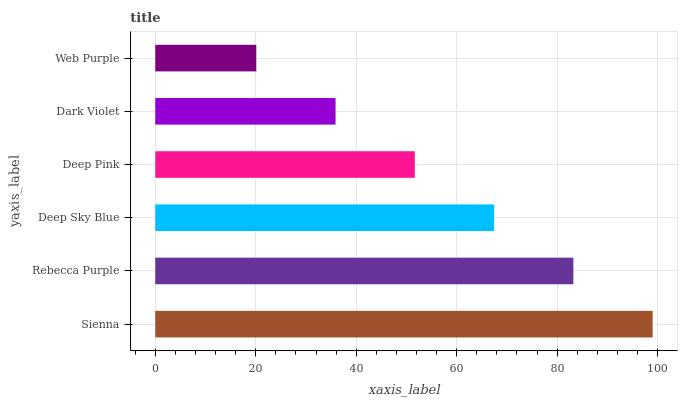Is Web Purple the minimum?
Answer yes or no. Yes. Is Sienna the maximum?
Answer yes or no. Yes. Is Rebecca Purple the minimum?
Answer yes or no. No. Is Rebecca Purple the maximum?
Answer yes or no. No. Is Sienna greater than Rebecca Purple?
Answer yes or no. Yes. Is Rebecca Purple less than Sienna?
Answer yes or no. Yes. Is Rebecca Purple greater than Sienna?
Answer yes or no. No. Is Sienna less than Rebecca Purple?
Answer yes or no. No. Is Deep Sky Blue the high median?
Answer yes or no. Yes. Is Deep Pink the low median?
Answer yes or no. Yes. Is Rebecca Purple the high median?
Answer yes or no. No. Is Sienna the low median?
Answer yes or no. No. 